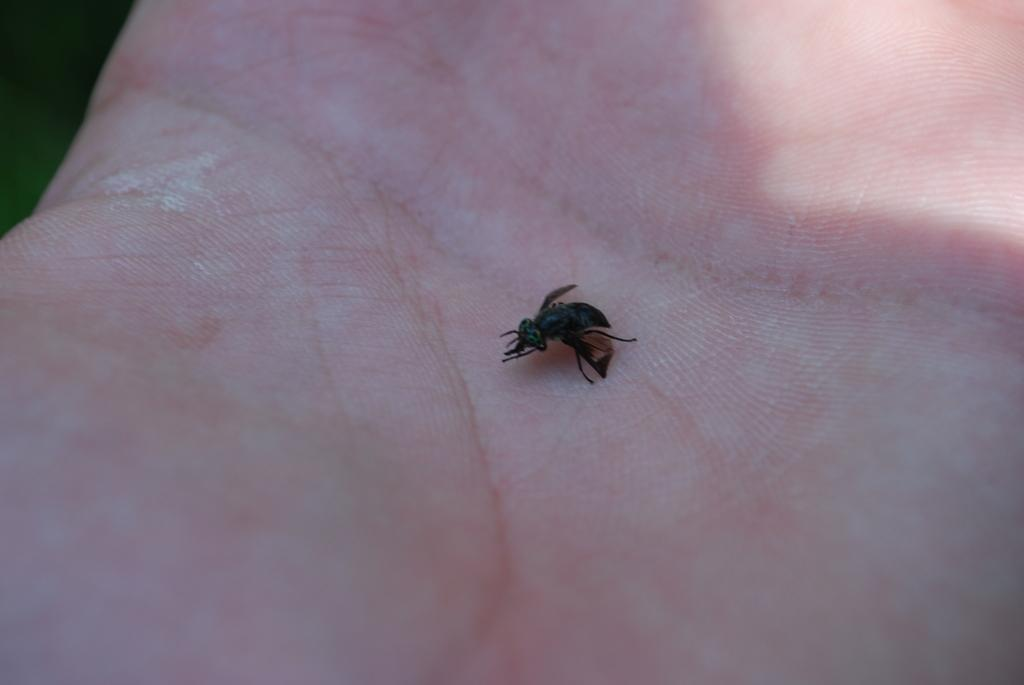What type of creature is present in the image? There is an insect in the image. Where is the insect located? The insect is on a palm in the image. What is the position of the palm in the image? The palm is in the center of the image. What type of birds can be seen flying around the insect in the image? There are no birds present in the image; it only features an insect on a palm. What type of badge is the insect wearing in the image? There is no badge present in the image; the insect is simply on a palm. 